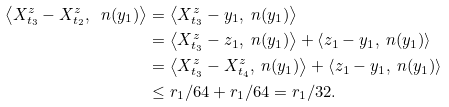Convert formula to latex. <formula><loc_0><loc_0><loc_500><loc_500>\left < X ^ { z } _ { t _ { 3 } } - X ^ { z } _ { t _ { 2 } } , \ n ( y _ { 1 } ) \right > & = \left < X ^ { z } _ { t _ { 3 } } - y _ { 1 } , \ n ( y _ { 1 } ) \right > \\ & = \left < X ^ { z } _ { t _ { 3 } } - z _ { 1 } , \ n ( y _ { 1 } ) \right > + \left < z _ { 1 } - y _ { 1 } , \ n ( y _ { 1 } ) \right > \\ & = \left < X ^ { z } _ { t _ { 3 } } - X ^ { z } _ { t _ { 4 } } , \ n ( y _ { 1 } ) \right > + \left < z _ { 1 } - y _ { 1 } , \ n ( y _ { 1 } ) \right > \\ & \leq r _ { 1 } / 6 4 + r _ { 1 } / 6 4 = r _ { 1 } / 3 2 .</formula> 